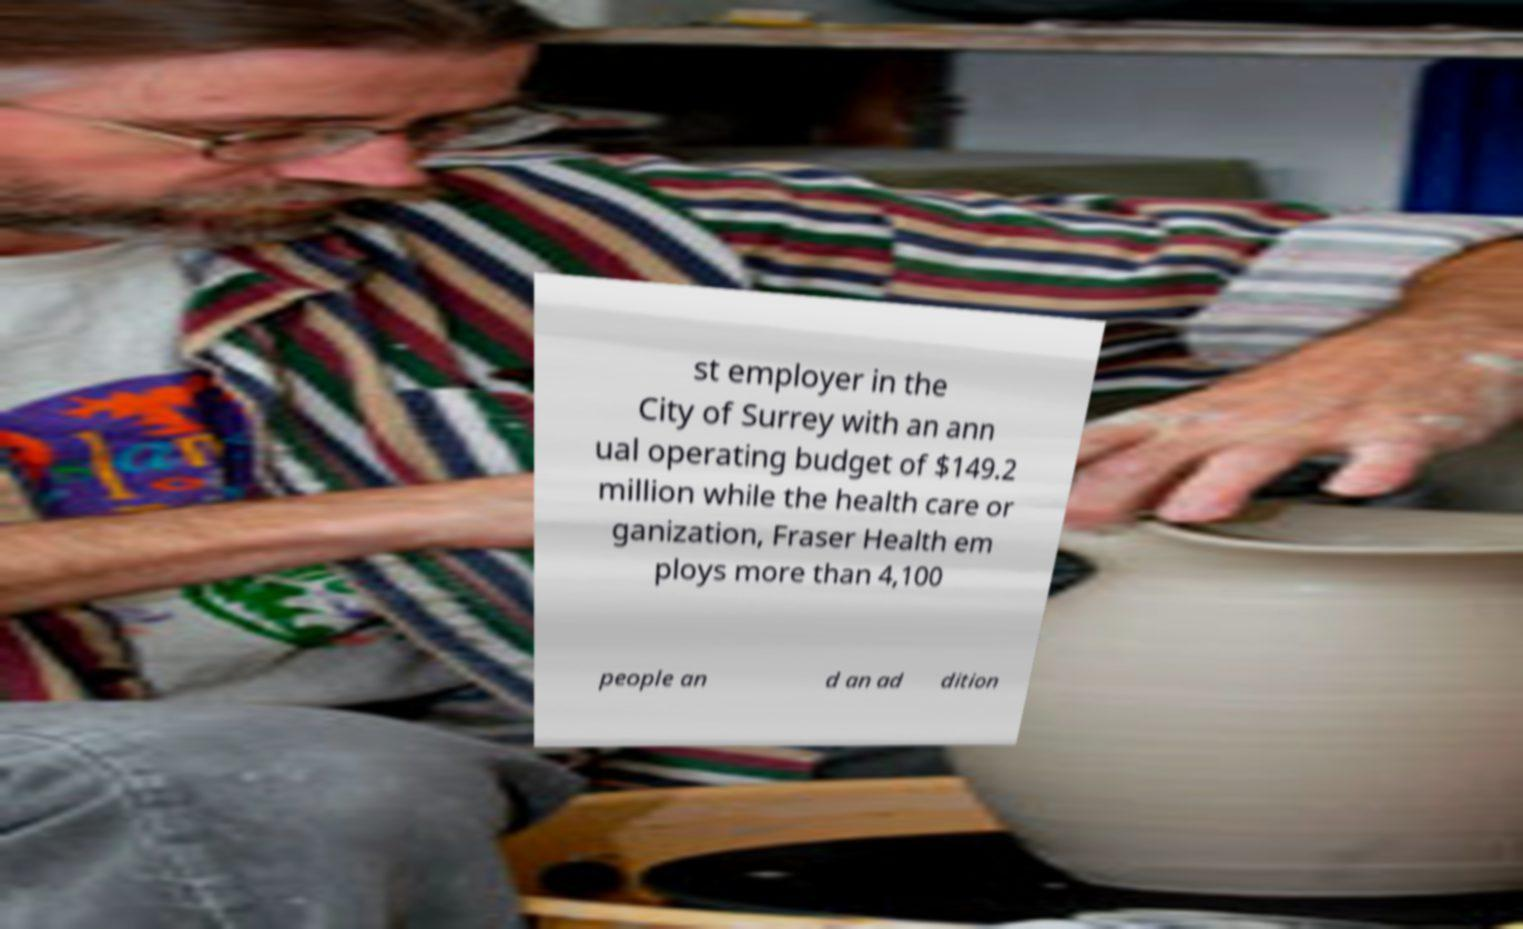For documentation purposes, I need the text within this image transcribed. Could you provide that? st employer in the City of Surrey with an ann ual operating budget of $149.2 million while the health care or ganization, Fraser Health em ploys more than 4,100 people an d an ad dition 